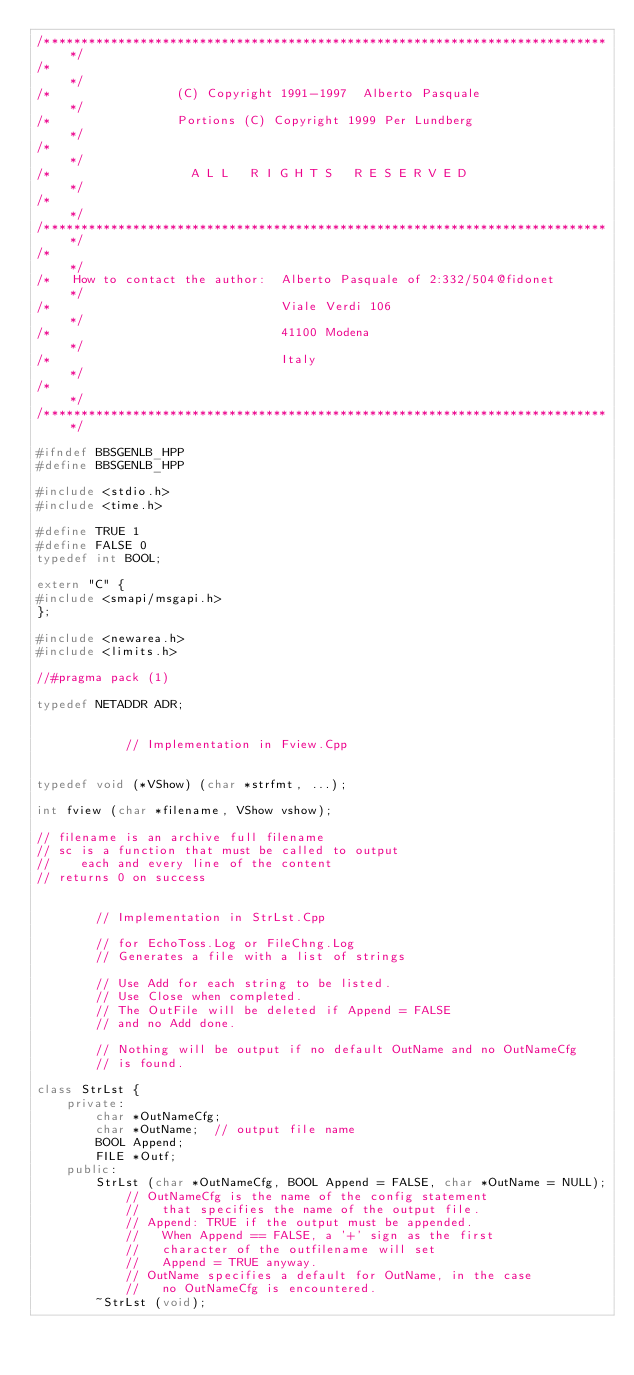<code> <loc_0><loc_0><loc_500><loc_500><_C++_>/*****************************************************************************/
/*                                                                           */
/*                 (C) Copyright 1991-1997  Alberto Pasquale                 */
/*                 Portions (C) Copyright 1999 Per Lundberg                  */
/*                                                                           */
/*                   A L L   R I G H T S   R E S E R V E D                   */
/*                                                                           */
/*****************************************************************************/
/*                                                                           */
/*   How to contact the author:  Alberto Pasquale of 2:332/504@fidonet       */
/*                               Viale Verdi 106                             */
/*                               41100 Modena                                */
/*                               Italy                                       */
/*                                                                           */
/*****************************************************************************/

#ifndef BBSGENLB_HPP
#define BBSGENLB_HPP

#include <stdio.h>
#include <time.h>

#define TRUE 1
#define FALSE 0
typedef int BOOL;

extern "C" {
#include <smapi/msgapi.h>
};

#include <newarea.h>
#include <limits.h>

//#pragma pack (1)

typedef NETADDR ADR;


            // Implementation in Fview.Cpp


typedef void (*VShow) (char *strfmt, ...);

int fview (char *filename, VShow vshow);

// filename is an archive full filename
// sc is a function that must be called to output
//    each and every line of the content
// returns 0 on success


        // Implementation in StrLst.Cpp

        // for EchoToss.Log or FileChng.Log
        // Generates a file with a list of strings

        // Use Add for each string to be listed.
        // Use Close when completed.
        // The OutFile will be deleted if Append = FALSE
        // and no Add done.

        // Nothing will be output if no default OutName and no OutNameCfg
        // is found.

class StrLst {
    private:
        char *OutNameCfg;
        char *OutName;  // output file name
        BOOL Append;
        FILE *Outf;
    public:
        StrLst (char *OutNameCfg, BOOL Append = FALSE, char *OutName = NULL);
            // OutNameCfg is the name of the config statement
            //   that specifies the name of the output file.
            // Append: TRUE if the output must be appended.
            //   When Append == FALSE, a '+' sign as the first
            //   character of the outfilename will set
            //   Append = TRUE anyway.
            // OutName specifies a default for OutName, in the case
            //   no OutNameCfg is encountered.
        ~StrLst (void);</code> 